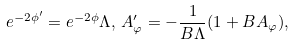Convert formula to latex. <formula><loc_0><loc_0><loc_500><loc_500>e ^ { - 2 \phi ^ { \prime } } = e ^ { - 2 \phi } \Lambda , \, A ^ { \prime } _ { \varphi } = - \frac { 1 } { B \Lambda } ( 1 + B A _ { \varphi } ) ,</formula> 